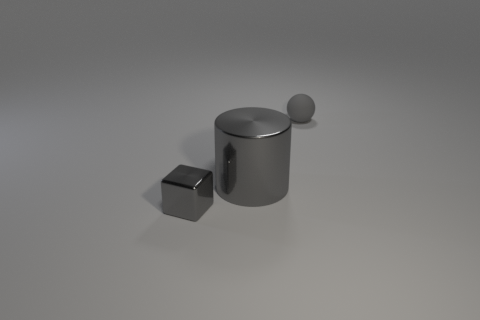What shape is the matte object that is the same color as the big cylinder?
Give a very brief answer. Sphere. There is a thing that is to the left of the gray cylinder; is it the same color as the small ball?
Provide a short and direct response. Yes. How many other things are made of the same material as the ball?
Make the answer very short. 0. Is the number of cylinders that are behind the gray sphere less than the number of small shiny cylinders?
Your response must be concise. No. Does the gray matte thing have the same shape as the small metallic thing?
Give a very brief answer. No. There is a thing that is behind the gray shiny thing that is behind the tiny object to the left of the gray rubber ball; what is its size?
Provide a succinct answer. Small. Is there any other thing that is the same size as the rubber thing?
Your response must be concise. Yes. There is a gray object that is in front of the gray shiny object right of the small gray metallic cube; what is its size?
Your answer should be compact. Small. The small rubber object has what color?
Ensure brevity in your answer.  Gray. How many gray things are to the left of the tiny gray object behind the big metallic cylinder?
Make the answer very short. 2. 